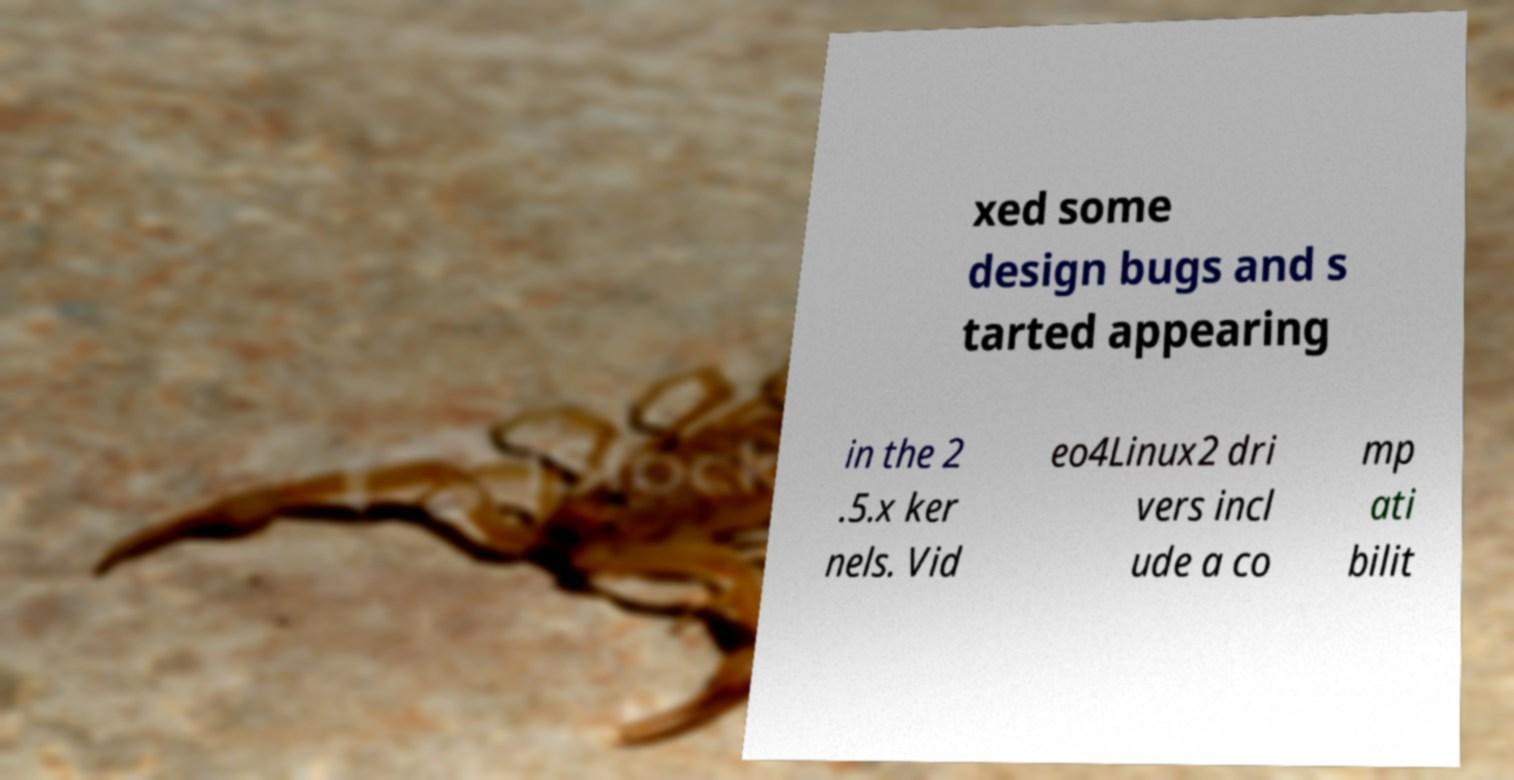Can you accurately transcribe the text from the provided image for me? xed some design bugs and s tarted appearing in the 2 .5.x ker nels. Vid eo4Linux2 dri vers incl ude a co mp ati bilit 